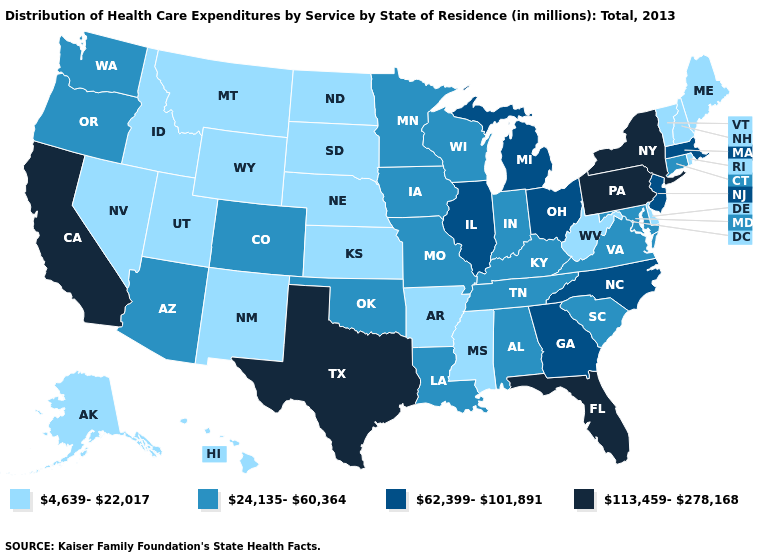Name the states that have a value in the range 62,399-101,891?
Keep it brief. Georgia, Illinois, Massachusetts, Michigan, New Jersey, North Carolina, Ohio. Does Montana have the lowest value in the West?
Keep it brief. Yes. What is the value of New Jersey?
Short answer required. 62,399-101,891. What is the value of Delaware?
Quick response, please. 4,639-22,017. What is the value of Ohio?
Short answer required. 62,399-101,891. How many symbols are there in the legend?
Keep it brief. 4. How many symbols are there in the legend?
Give a very brief answer. 4. Does Colorado have the lowest value in the West?
Write a very short answer. No. Name the states that have a value in the range 4,639-22,017?
Concise answer only. Alaska, Arkansas, Delaware, Hawaii, Idaho, Kansas, Maine, Mississippi, Montana, Nebraska, Nevada, New Hampshire, New Mexico, North Dakota, Rhode Island, South Dakota, Utah, Vermont, West Virginia, Wyoming. What is the value of Iowa?
Quick response, please. 24,135-60,364. Does Alaska have the lowest value in the West?
Short answer required. Yes. Among the states that border Maryland , which have the lowest value?
Be succinct. Delaware, West Virginia. What is the value of Mississippi?
Concise answer only. 4,639-22,017. What is the value of Kentucky?
Quick response, please. 24,135-60,364. Name the states that have a value in the range 4,639-22,017?
Short answer required. Alaska, Arkansas, Delaware, Hawaii, Idaho, Kansas, Maine, Mississippi, Montana, Nebraska, Nevada, New Hampshire, New Mexico, North Dakota, Rhode Island, South Dakota, Utah, Vermont, West Virginia, Wyoming. 